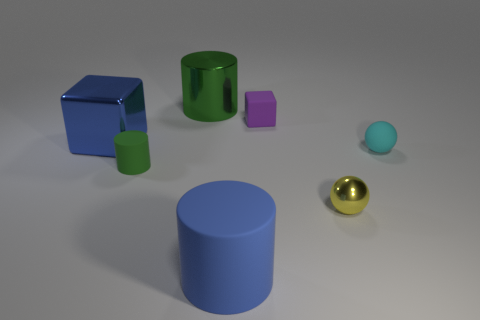Add 3 cyan metallic spheres. How many objects exist? 10 Subtract all spheres. How many objects are left? 5 Add 1 small cyan spheres. How many small cyan spheres exist? 2 Subtract 0 purple cylinders. How many objects are left? 7 Subtract all small rubber spheres. Subtract all tiny metal balls. How many objects are left? 5 Add 1 large metal objects. How many large metal objects are left? 3 